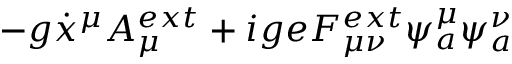<formula> <loc_0><loc_0><loc_500><loc_500>- g \dot { x } ^ { \mu } A _ { \mu } ^ { e x t } + i g e F _ { \mu \nu } ^ { e x t } \psi _ { a } ^ { \mu } \psi _ { a } ^ { \nu }</formula> 